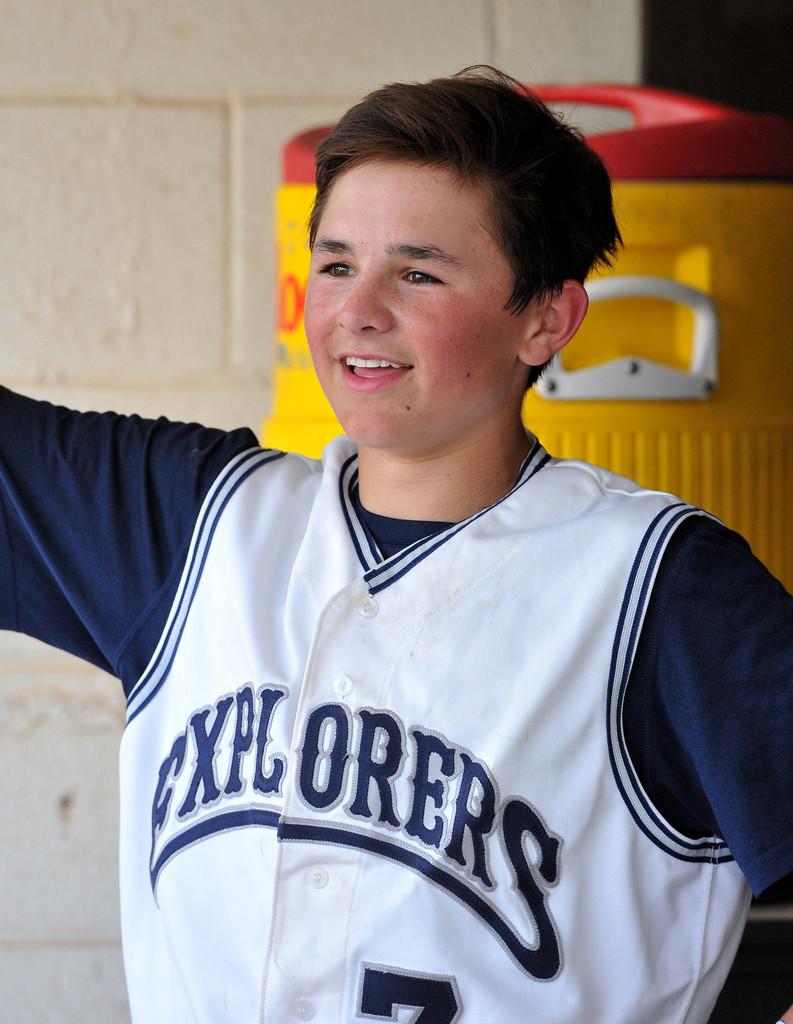Is he wearing an explorer's jersey?
Offer a very short reply. Yes. 